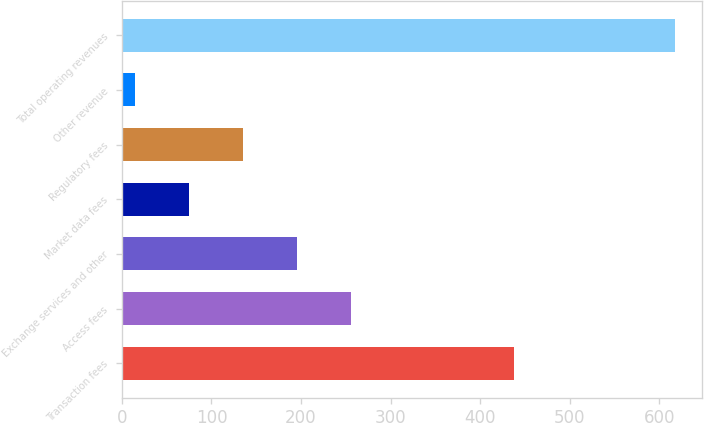Convert chart to OTSL. <chart><loc_0><loc_0><loc_500><loc_500><bar_chart><fcel>Transaction fees<fcel>Access fees<fcel>Exchange services and other<fcel>Market data fees<fcel>Regulatory fees<fcel>Other revenue<fcel>Total operating revenues<nl><fcel>437.8<fcel>255.64<fcel>195.38<fcel>74.86<fcel>135.12<fcel>14.6<fcel>617.2<nl></chart> 